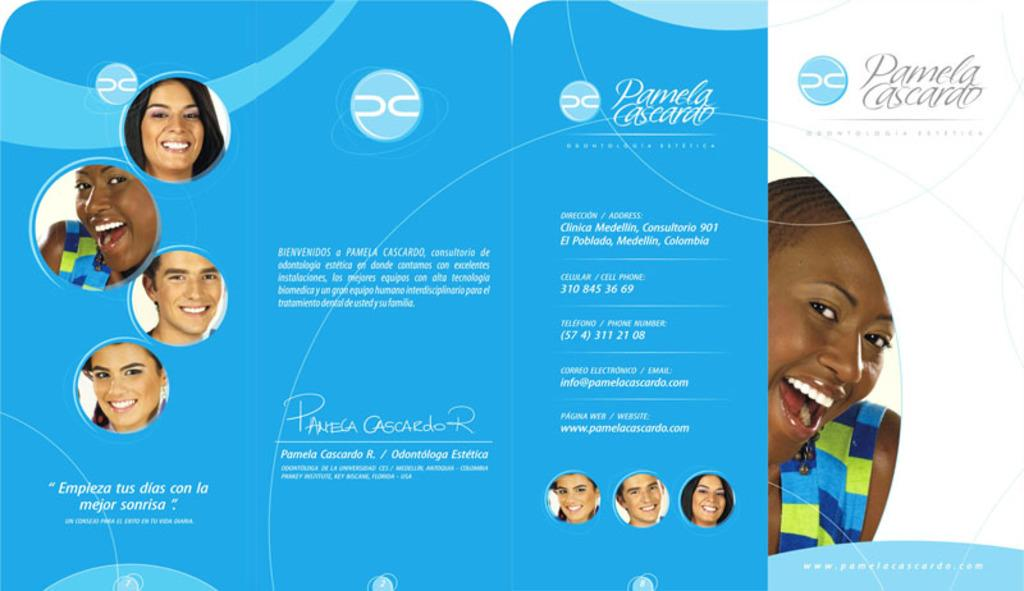What is the main subject of the poster in the image? The poster contains pictures of people. What else can be found on the poster besides the images of people? There is text on the poster. How many elbows are visible in the poster? There is no mention of elbows in the image or the poster; it only contains pictures of people and text. 